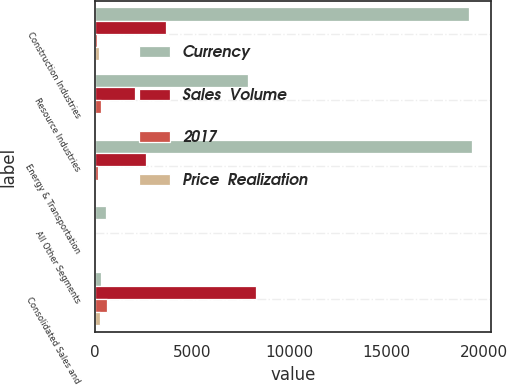Convert chart to OTSL. <chart><loc_0><loc_0><loc_500><loc_500><stacked_bar_chart><ecel><fcel>Construction Industries<fcel>Resource Industries<fcel>Energy & Transportation<fcel>All Other Segments<fcel>Consolidated Sales and<nl><fcel>Currency<fcel>19240<fcel>7861<fcel>19382<fcel>570<fcel>316<nl><fcel>Sales  Volume<fcel>3663<fcel>2082<fcel>2637<fcel>26<fcel>8291<nl><fcel>2017<fcel>122<fcel>316<fcel>163<fcel>1<fcel>601<nl><fcel>Price  Realization<fcel>198<fcel>14<fcel>68<fcel>3<fcel>254<nl></chart> 